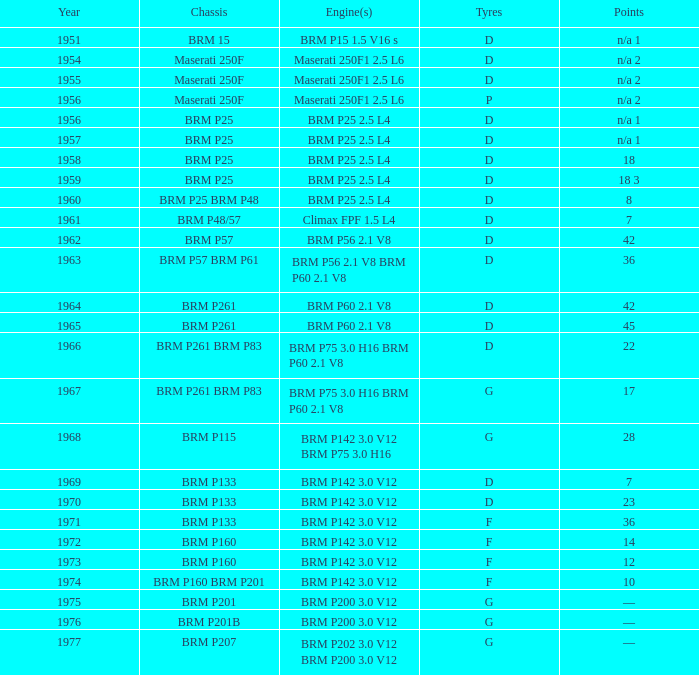Name the point for 1974 10.0. 